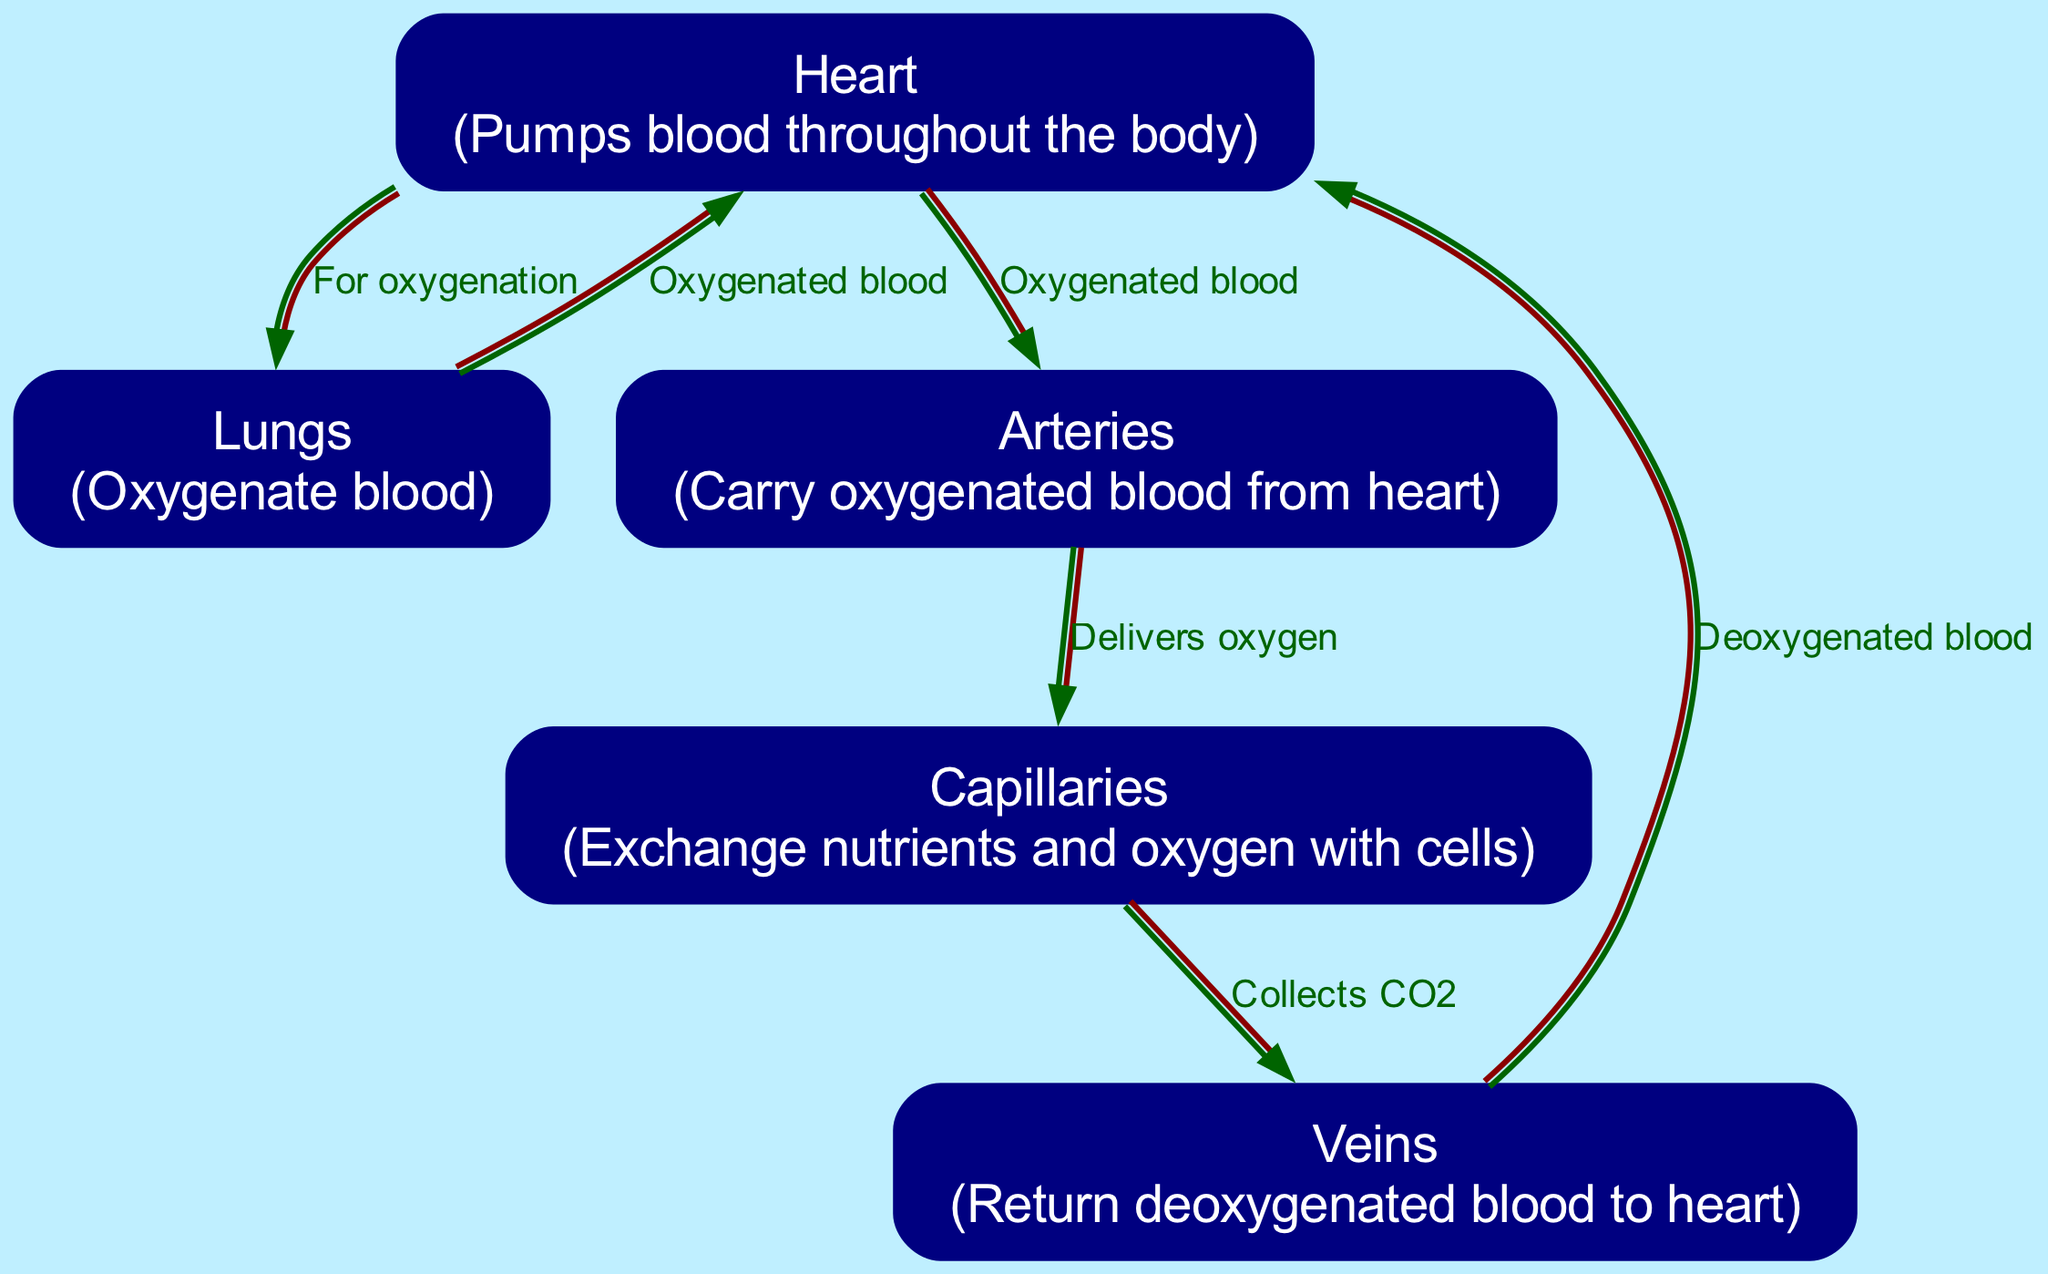What part of the circulatory system pumps blood? From the diagram, the "Heart" is labeled as the part that pumps blood throughout the body.
Answer: Heart How does oxygenated blood leave the heart? The diagram indicates that oxygenated blood exits the "Heart" and travels through the "Arteries".
Answer: Arteries What is the role of capillaries in the body? According to the diagram, "Capillaries" are responsible for exchanging nutrients and oxygen with cells, which is their primary function in the circulatory system.
Answer: Exchange nutrients and oxygen How many main components are represented in the circulatory system diagram? The diagram includes five main components: Heart, Lungs, Arteries, Veins, and Capillaries; thus there are five nodes depicted.
Answer: Five Where does deoxygenated blood go after reaching the veins? The diagram shows that deoxygenated blood travels from the "Veins" back to the "Heart" after it collects CO2.
Answer: Heart What transports oxygenated blood from the lungs to the heart? As per the diagram, "Lungs" send oxygenated blood back to the "Heart". This flow indicates the essential role of the lungs in oxygenating blood.
Answer: Heart What is delivered by the arteries to the capillaries? The diagram explicitly states that the "Arteries" deliver oxygen to the "Capillaries", facilitating oxygen transfer to body tissues.
Answer: Oxygen Which part of the circulatory system collects CO2? The "Capillaries" are shown to collect CO2 after exchanging oxygen, marking their role in removing carbon dioxide from tissues.
Answer: Capillaries What flow direction is indicated between the heart and lungs? The diagram illustrates that the flow of blood from the "Heart" to the "Lungs" is for the purpose of oxygenation, indicating a one-way direction for blood flow in that sector.
Answer: For oxygenation What returns deoxygenated blood back to the heart? The "Veins" are specifically labeled as the vessels that return deoxygenated blood to the "Heart", completing the cycle of blood circulation.
Answer: Veins 